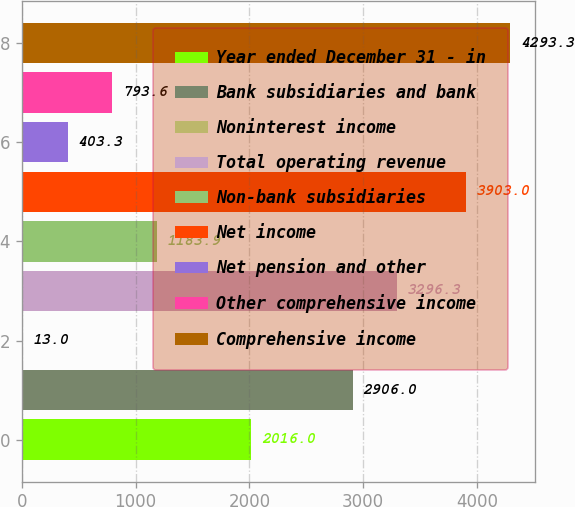Convert chart. <chart><loc_0><loc_0><loc_500><loc_500><bar_chart><fcel>Year ended December 31 - in<fcel>Bank subsidiaries and bank<fcel>Noninterest income<fcel>Total operating revenue<fcel>Non-bank subsidiaries<fcel>Net income<fcel>Net pension and other<fcel>Other comprehensive income<fcel>Comprehensive income<nl><fcel>2016<fcel>2906<fcel>13<fcel>3296.3<fcel>1183.9<fcel>3903<fcel>403.3<fcel>793.6<fcel>4293.3<nl></chart> 